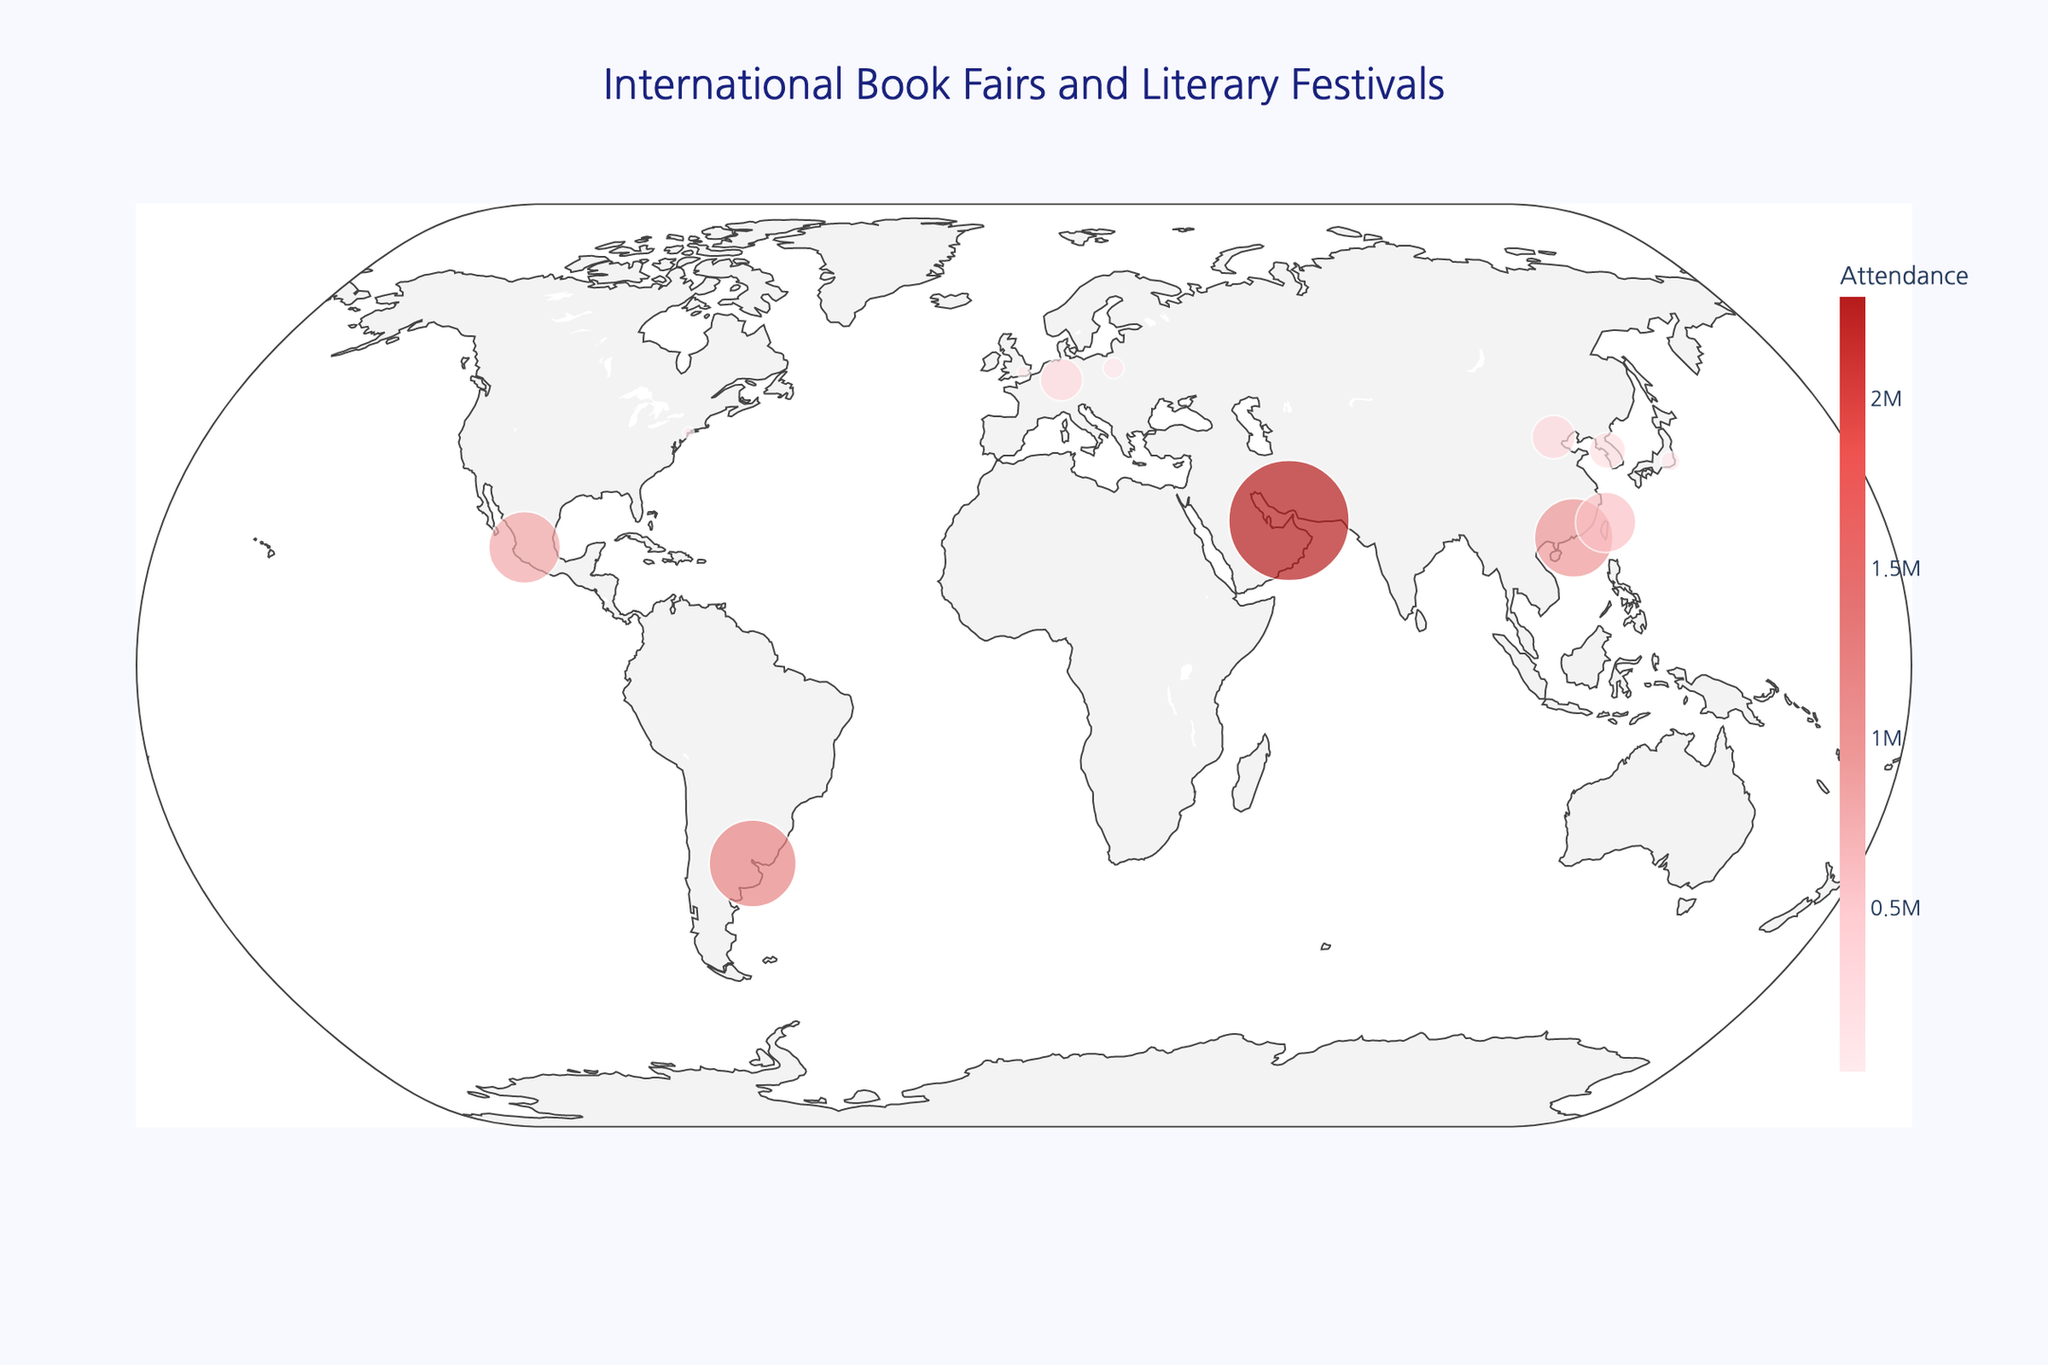What is the title of the map? The title is centered at the top and prominently displays the subject of the map.
Answer: International Book Fairs and Literary Festivals How many book fairs are marked in Asia? Asian book fairs include those in South Korea, Japan, China (2), Hong Kong, and Taiwan.
Answer: 6 Which city hosts the book fair with the highest attendance? By looking at the size of the circles and the hover information, it's clear that the largest attendance is in Sharjah, UAE.
Answer: Sharjah What is the difference in attendance between the Seoul International Book Fair and the Tokyo International Book Fair? Seoul has 210,000 attendees and Tokyo has 60,000 attendees. The difference is 210,000 - 60,000.
Answer: 150,000 Which book fair is geographically closest to Seoul International Book Fair? The closest by latitude and longitude is likely to be Tokyo.
Answer: Tokyo Which European book fair has the highest attendance? In Europe, the Frankfurt Book Fair in Germany marks the highest attendance when inspecting the size of the markers.
Answer: Frankfurt What is the average attendance of the book fairs held in China? There are two fairs in China (Beijing: 300,000 and Hong Kong: 980,000). The average is (300,000 + 980,000) / 2.
Answer: 640,000 Which event has smaller attendance, Taipei International Book Exhibition or London Book Fair? Comparing the displayed sizes, London Book Fair attendance is 25,000 and Taipei International Book Exhibition is 580,000.
Answer: London Book Fair What's the median attendance value of all the book fairs shown? First list the values (20,000, 25,000, 60,000, 70,000, 210,000, 285,000, 300,000, 580,000, 980,000, 1,200,000, 2,300,000) and then find the median (middle value).
Answer: 285,000 Name three book fairs with the smallest attendance. By reviewing the circle sizes and hover information, the smallest attendances are BookExpo America (New York), London Book Fair, and Tokyo International Book Fair.
Answer: BookExpo America, London Book Fair, Tokyo International Book Fair 